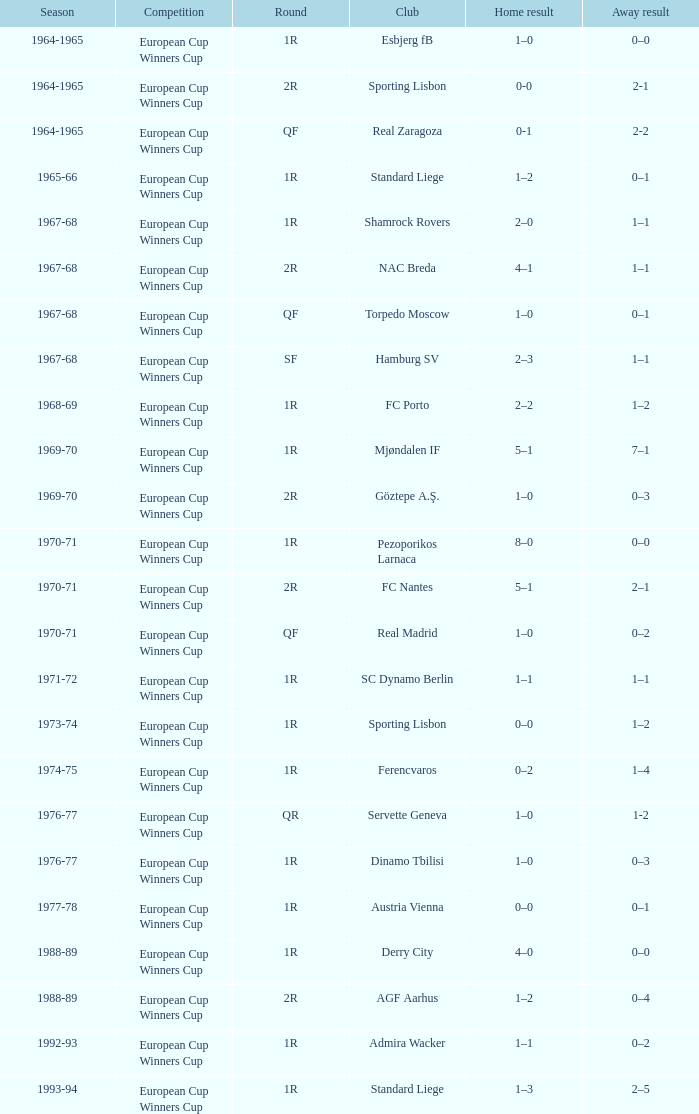Away result of 0–3, and a Season of 1969-70 is what competition? European Cup Winners Cup. 